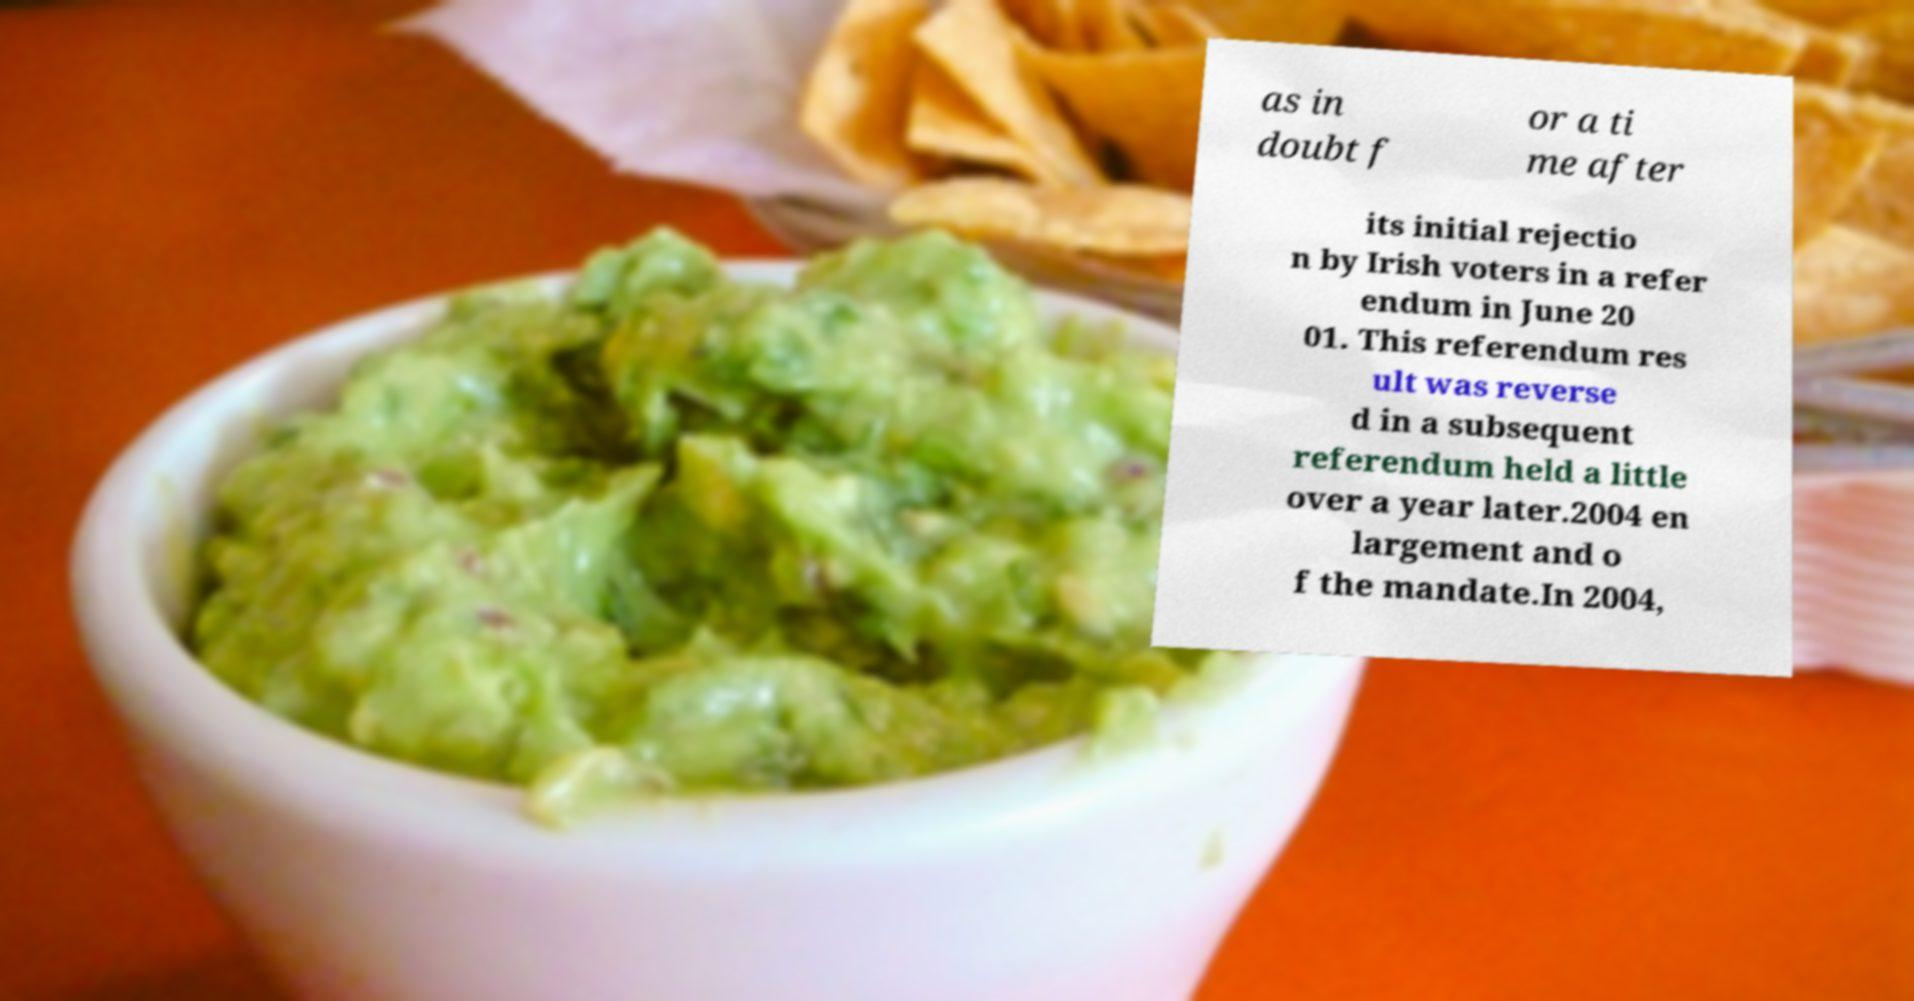Please read and relay the text visible in this image. What does it say? as in doubt f or a ti me after its initial rejectio n by Irish voters in a refer endum in June 20 01. This referendum res ult was reverse d in a subsequent referendum held a little over a year later.2004 en largement and o f the mandate.In 2004, 